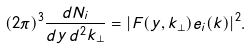<formula> <loc_0><loc_0><loc_500><loc_500>( 2 \pi ) ^ { 3 } \frac { d N _ { i } } { d y \, d ^ { 2 } { k } _ { \bot } } = | F ( y , { k } _ { \bot } ) e _ { i } ( { k } ) | ^ { 2 } .</formula> 